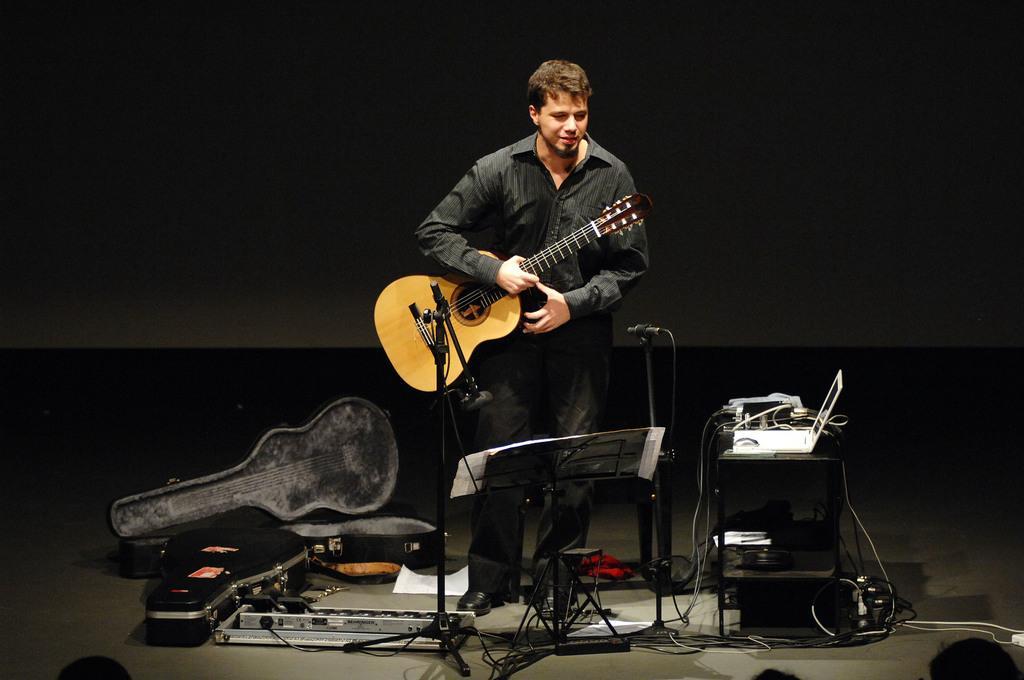Could you give a brief overview of what you see in this image? There is man who is standing holding a guitar in his hand. He is wearing black shirt and pant. In front him there is a stand. To the stand a paper is attached. There is a mic beside him , and a table on which there is laptop and wires. On the ground there are guitar cases. 